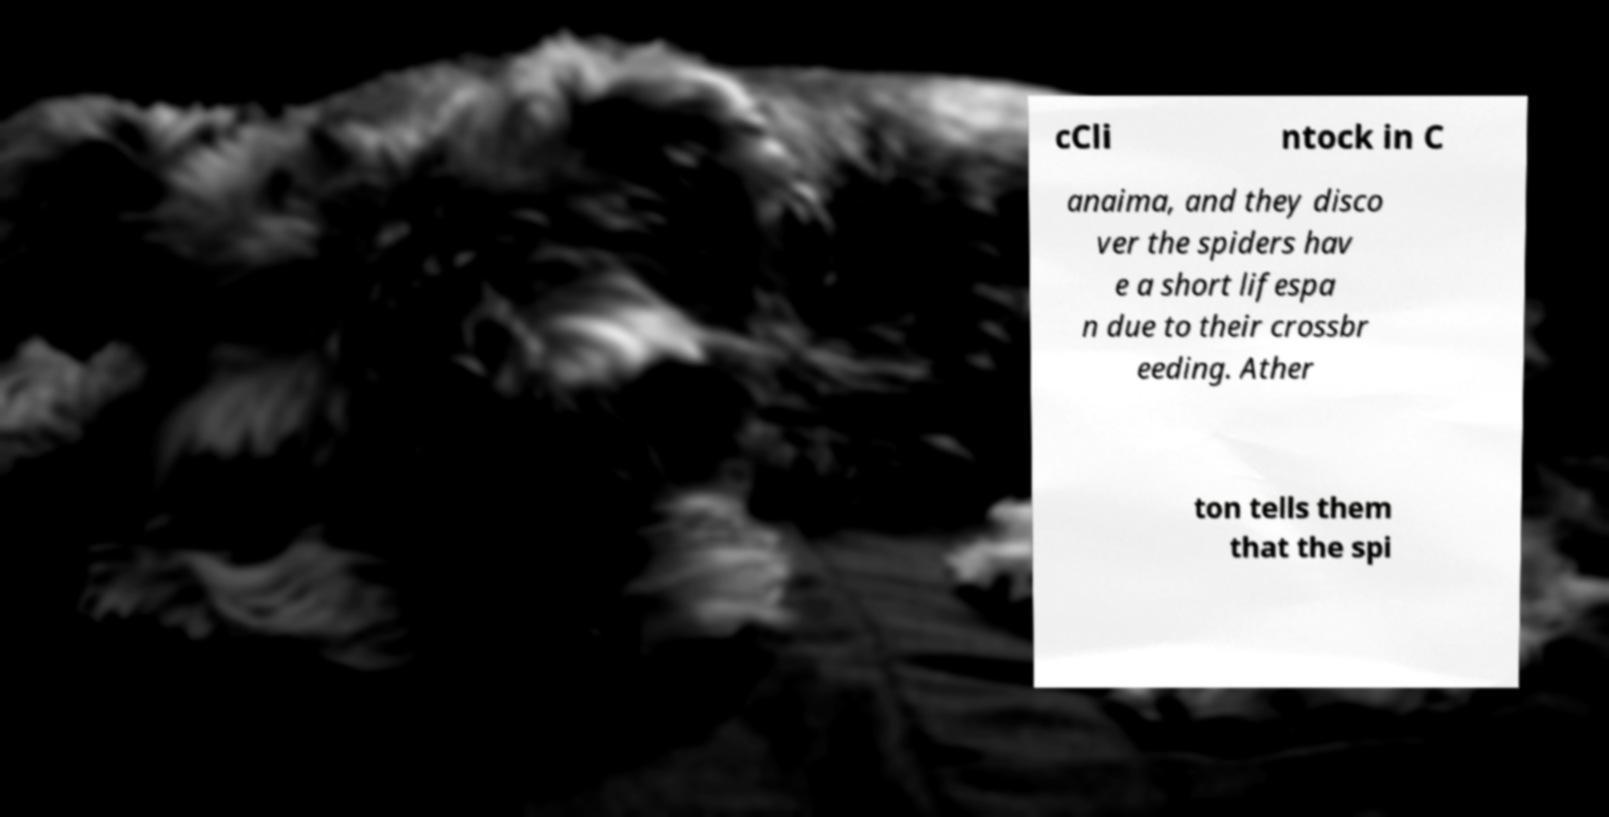Could you assist in decoding the text presented in this image and type it out clearly? cCli ntock in C anaima, and they disco ver the spiders hav e a short lifespa n due to their crossbr eeding. Ather ton tells them that the spi 